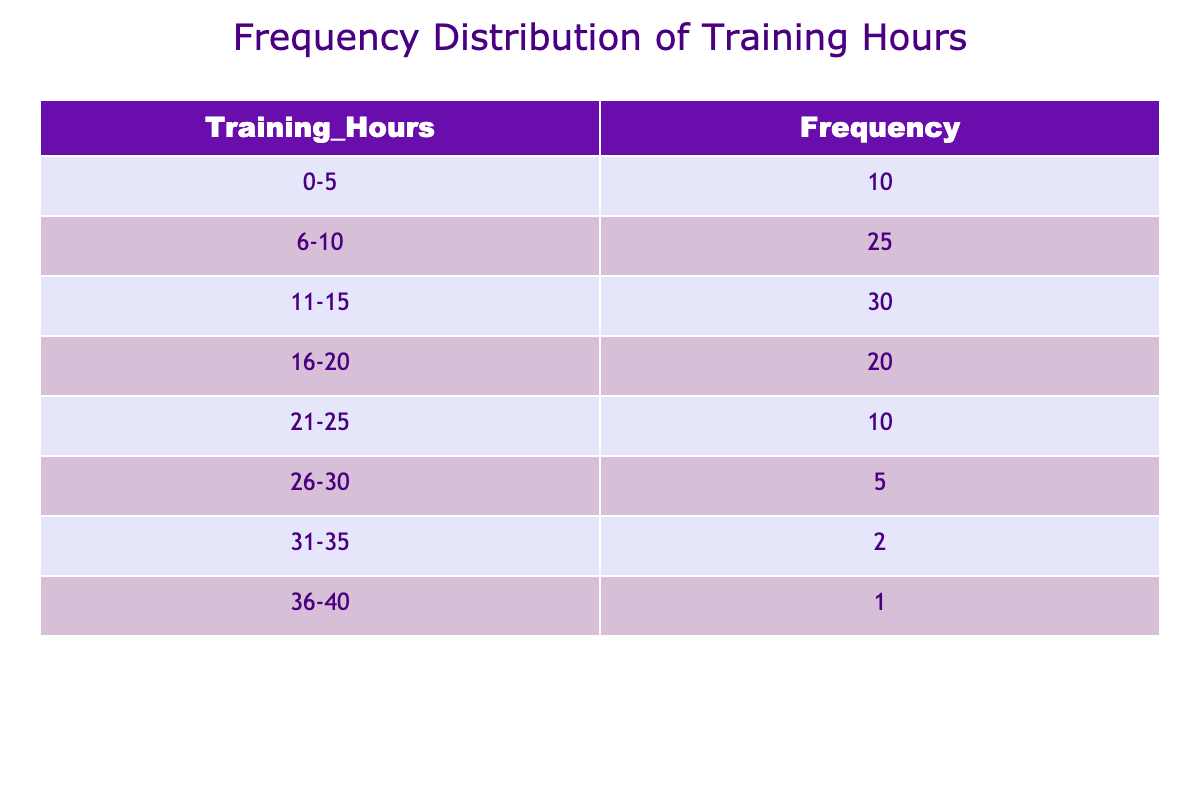What is the frequency of ultramarathon runners training 11-15 hours per week? The frequency for the training duration of 11-15 hours is directly stated in the table. It shows that there are 30 runners in that category.
Answer: 30 How many runners train for 21-25 hours or more per week? To find this, we need to add the frequencies for the 21-25, 26-30, 31-35, and 36-40 hour categories. That's 10 (21-25) + 5 (26-30) + 2 (31-35) + 1 (36-40) = 18 runners total.
Answer: 18 Is there a higher frequency of runners training in the 6-10 hour range compared to those in the 36-40 hour range? The table indicates that there are 25 runners in the 6-10 hour range and only 1 runner in the 36-40 hour range. Since 25 is greater than 1, the statement is true.
Answer: Yes What is the difference in frequency between the 11-15 hour and 16-20 hour training categories? The frequency for 11-15 hours is 30, and for 16-20 hours, it is 20. The difference is calculated as 30 - 20 = 10.
Answer: 10 What percentage of ultramarathon runners train for 0-5 hours per week? The frequency for 0-5 hours is 10, and the total frequency is the sum of all frequencies: 10 + 25 + 30 + 20 + 10 + 5 + 2 + 1 = 113. The percentage is calculated as (10 / 113) * 100 ≈ 8.85%.
Answer: Approximately 8.85% How many runners train for less than 10 hours per week? To find the total for less than 10 hours, we need to sum the frequencies for the 0-5 and 6-10 hour categories. That is 10 (0-5) + 25 (6-10) = 35 runners total.
Answer: 35 Are there more runners in the 16-20 hour category than the 26-30 hour category? The frequency for 16-20 hours is 20, while for 26-30 hours it is only 5. Since 20 is greater than 5, the statement is true.
Answer: Yes What is the total frequency of runners training between 11 and 20 hours per week? To get this total, we sum the frequencies for the 11-15 and 16-20 hour ranges: 30 (11-15) + 20 (16-20) = 50 runners total.
Answer: 50 